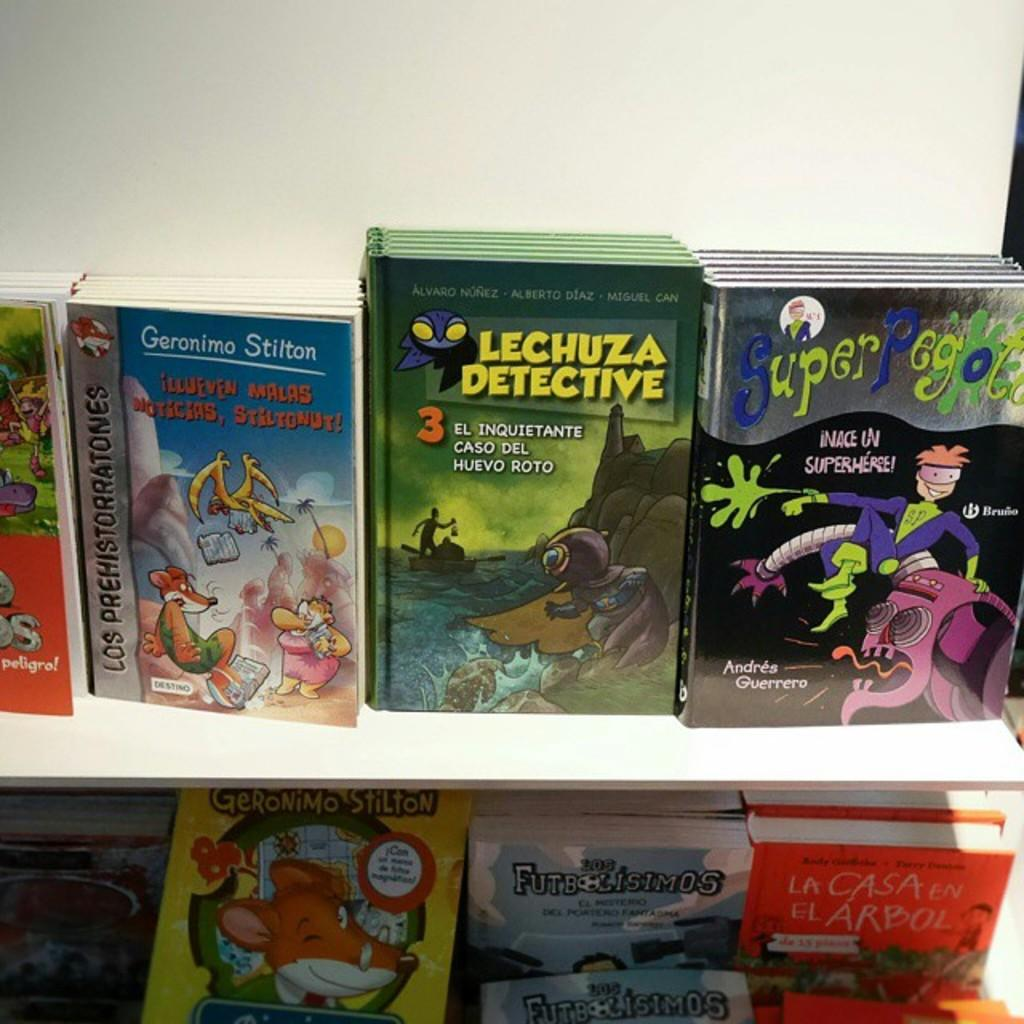<image>
Write a terse but informative summary of the picture. A display of children's books includes "Lechuza Detective. 